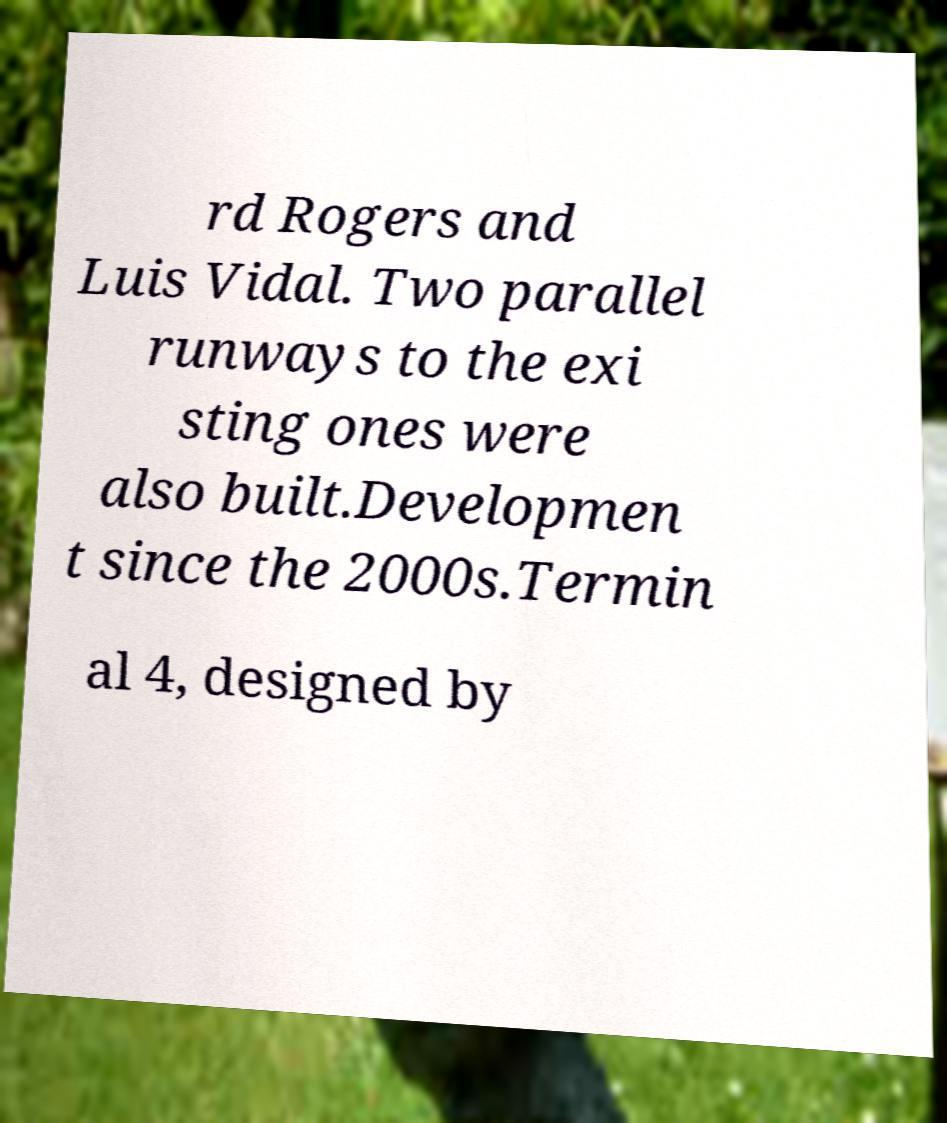I need the written content from this picture converted into text. Can you do that? rd Rogers and Luis Vidal. Two parallel runways to the exi sting ones were also built.Developmen t since the 2000s.Termin al 4, designed by 